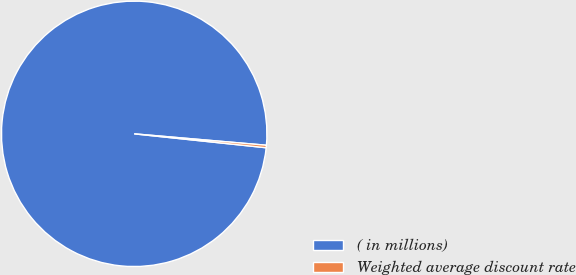<chart> <loc_0><loc_0><loc_500><loc_500><pie_chart><fcel>( in millions)<fcel>Weighted average discount rate<nl><fcel>99.7%<fcel>0.3%<nl></chart> 